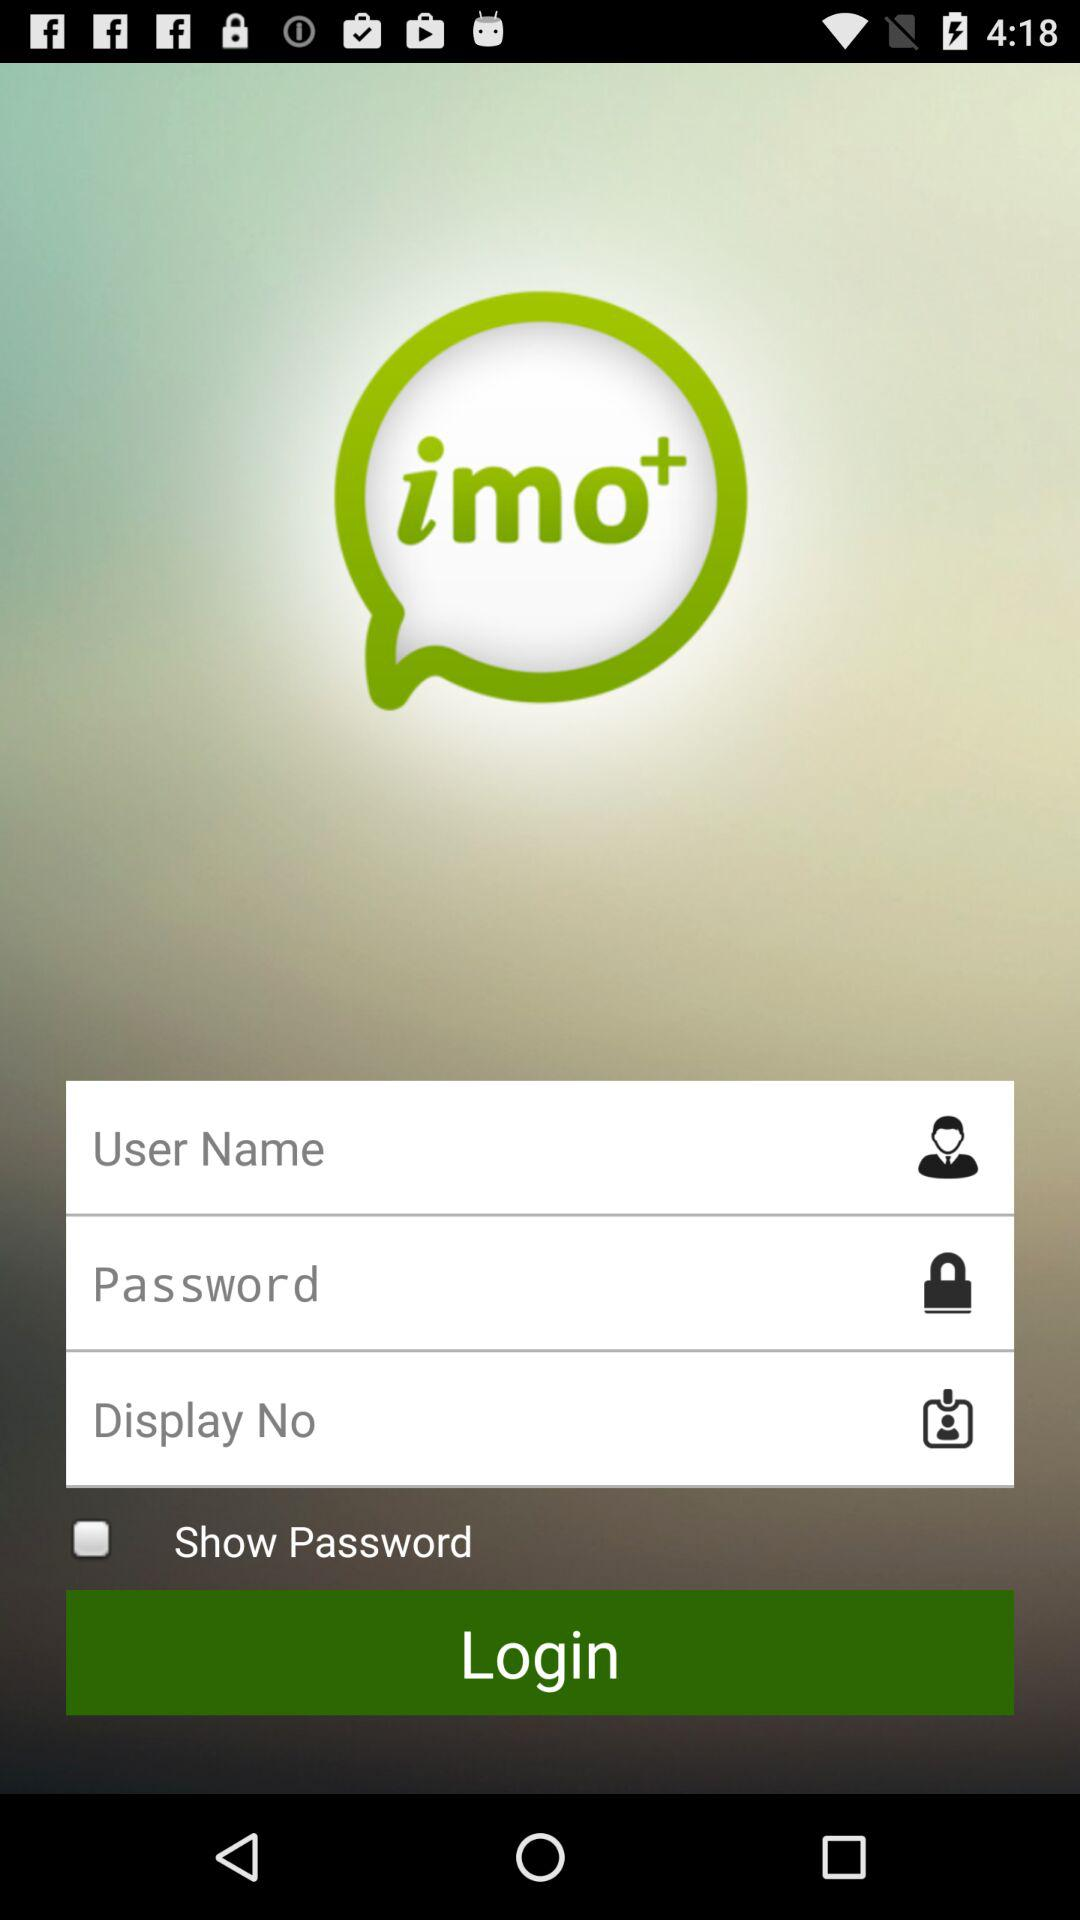What is the application name? The application name is "imo+". 